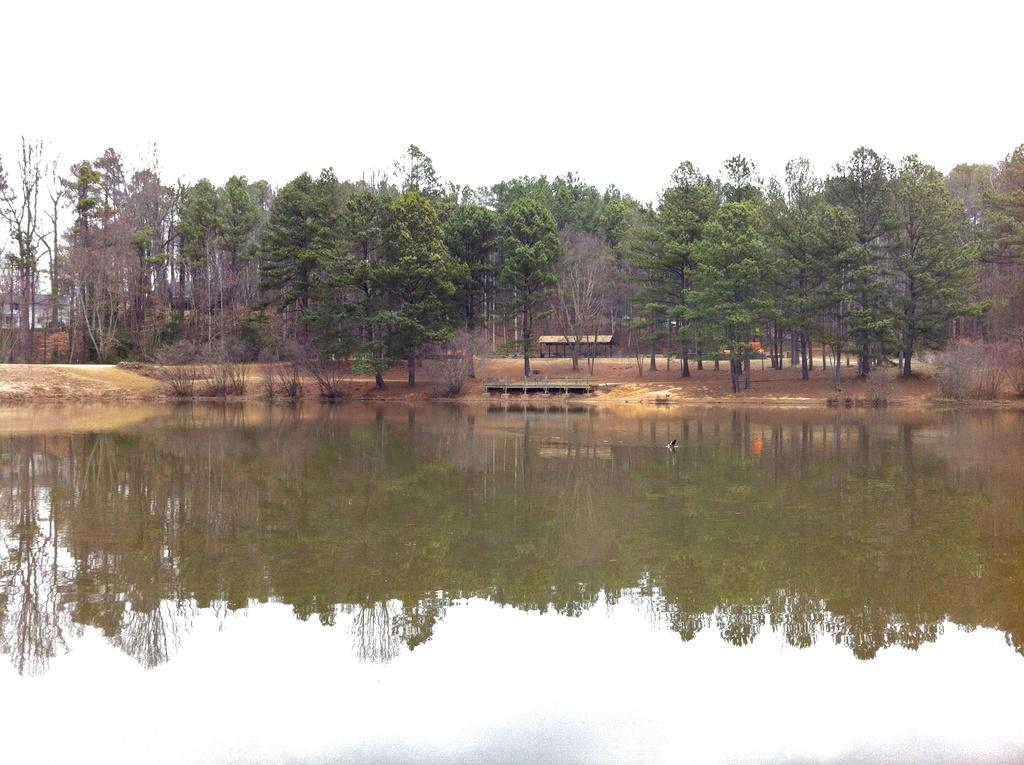What type of natural environment is depicted in the image? There is a large group of trees and plants in the image. What is the other main element visible in the image? There is water visible in the image. Can you describe any man-made structures in the image? There is a house with a roof in the image. What is visible in the background of the image? The sky is visible in the image. How would you describe the weather based on the image? The sky appears to be cloudy in the image. Can you tell me how many donkeys are present in the image? There are no donkeys present in the image. What type of adjustment is being made to the house in the image? There is no adjustment being made to the house in the image; it is a complete structure. 